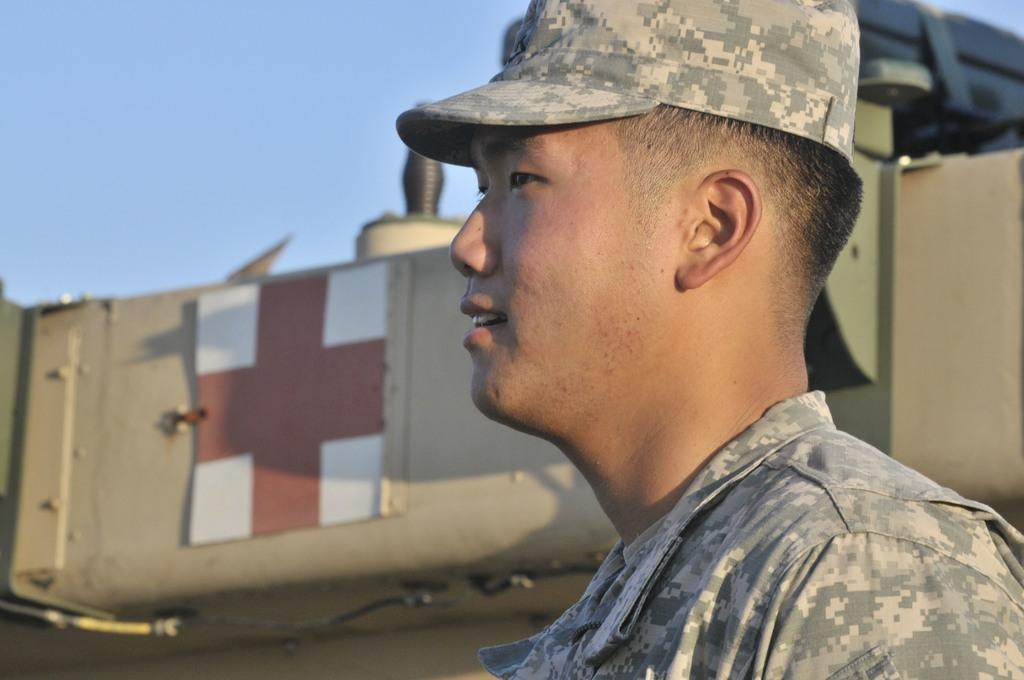What is the main subject of the image? There is a person in the image. What type of clothing is the person wearing? The person is wearing an army uniform. What type of headwear is the person wearing? The person is wearing a cap. What is the person's facial expression in the image? The person is smiling. What can be seen in the background of the image? There is a vehicle in the background of the image. What color is the sky in the image? The sky is blue in the image. What is the zephyr's tendency in the image? There is no zephyr present in the image, so it is not possible to determine its tendency. 